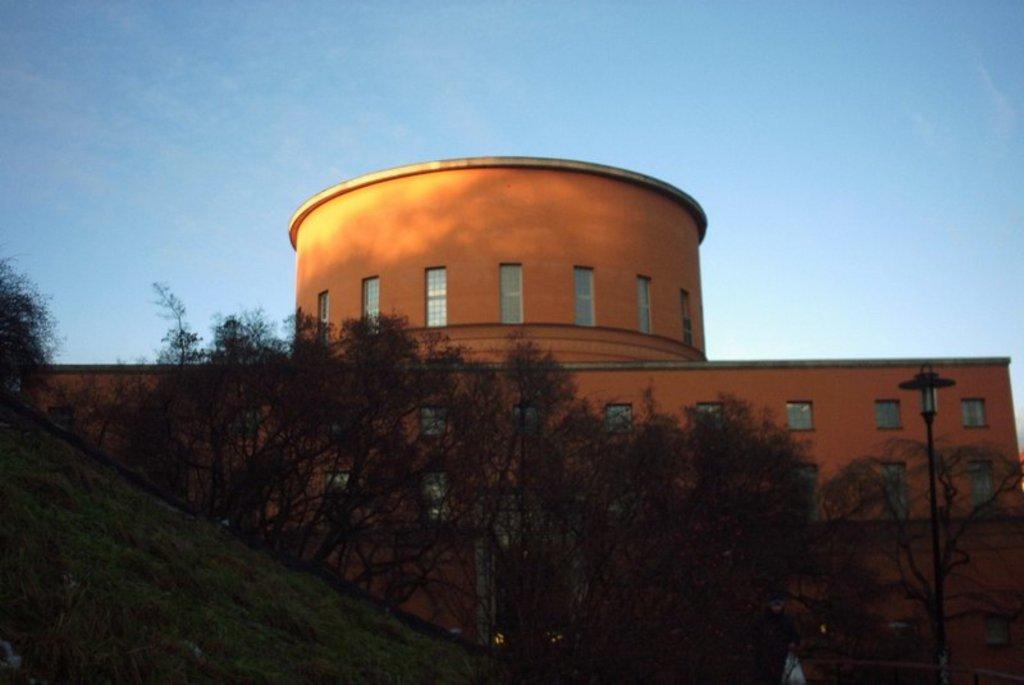Describe this image in one or two sentences. As we can see in the image there are trees, buildings, windows and a sky. 